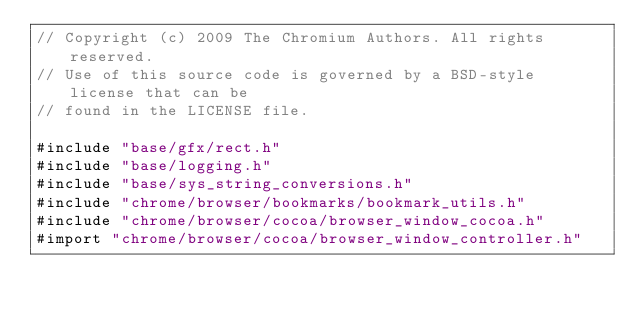<code> <loc_0><loc_0><loc_500><loc_500><_ObjectiveC_>// Copyright (c) 2009 The Chromium Authors. All rights reserved.
// Use of this source code is governed by a BSD-style license that can be
// found in the LICENSE file.

#include "base/gfx/rect.h"
#include "base/logging.h"
#include "base/sys_string_conversions.h"
#include "chrome/browser/bookmarks/bookmark_utils.h"
#include "chrome/browser/cocoa/browser_window_cocoa.h"
#import "chrome/browser/cocoa/browser_window_controller.h"</code> 